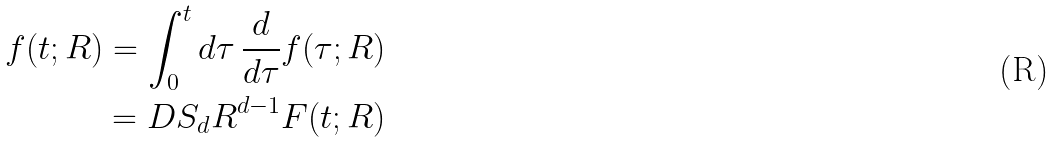Convert formula to latex. <formula><loc_0><loc_0><loc_500><loc_500>f ( t ; R ) = \int _ { 0 } ^ { t } d \tau \, \frac { d } { d \tau } f ( \tau ; R ) \\ = D S _ { d } R ^ { d - 1 } F ( t ; R )</formula> 